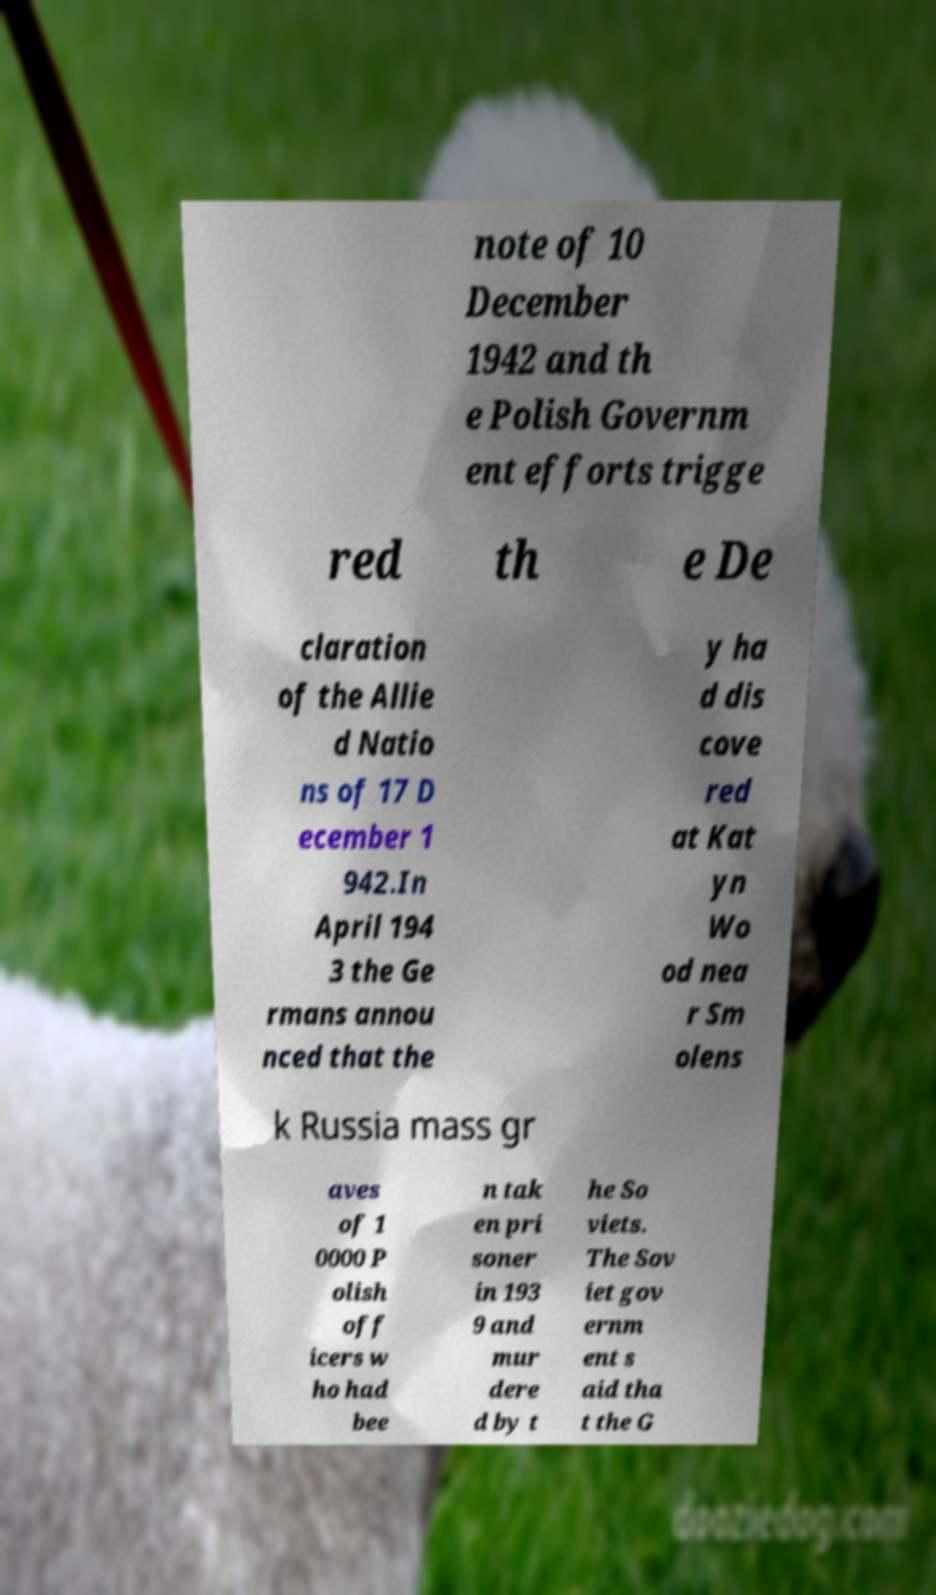There's text embedded in this image that I need extracted. Can you transcribe it verbatim? note of 10 December 1942 and th e Polish Governm ent efforts trigge red th e De claration of the Allie d Natio ns of 17 D ecember 1 942.In April 194 3 the Ge rmans annou nced that the y ha d dis cove red at Kat yn Wo od nea r Sm olens k Russia mass gr aves of 1 0000 P olish off icers w ho had bee n tak en pri soner in 193 9 and mur dere d by t he So viets. The Sov iet gov ernm ent s aid tha t the G 